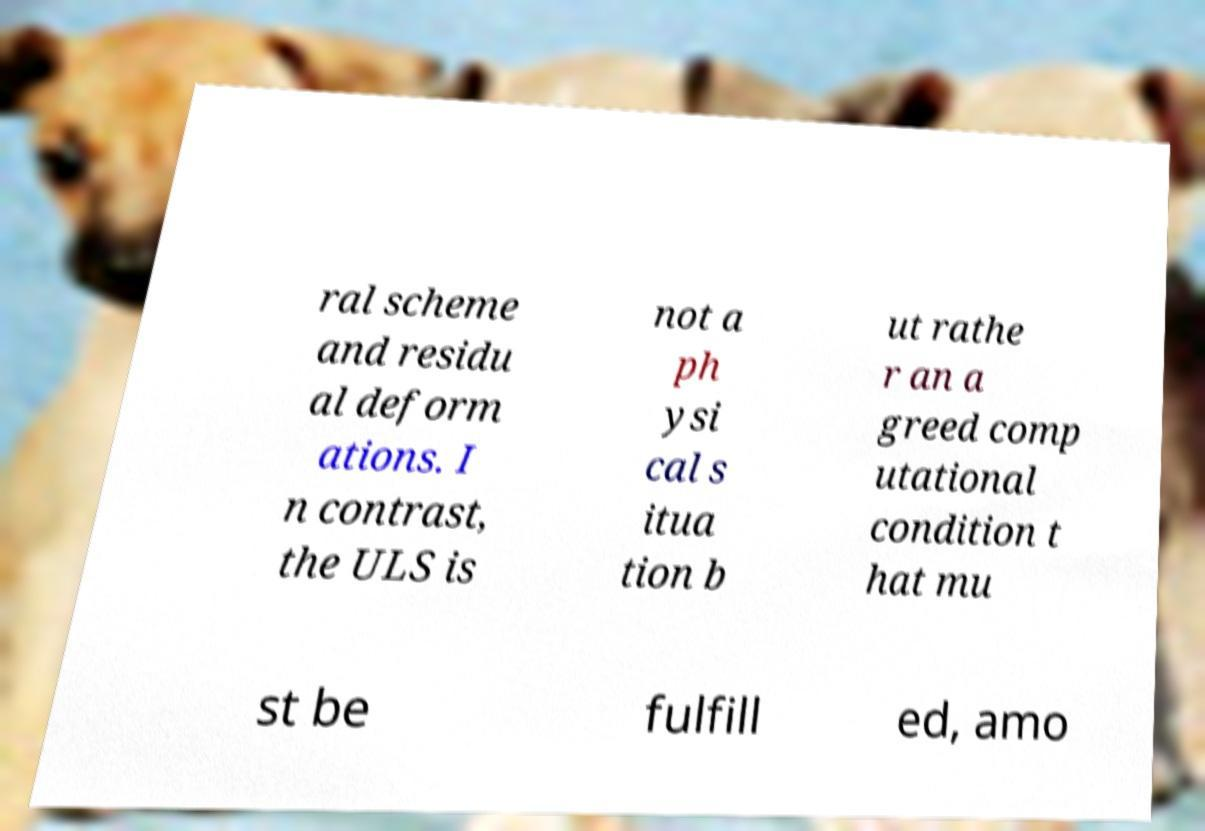What messages or text are displayed in this image? I need them in a readable, typed format. ral scheme and residu al deform ations. I n contrast, the ULS is not a ph ysi cal s itua tion b ut rathe r an a greed comp utational condition t hat mu st be fulfill ed, amo 